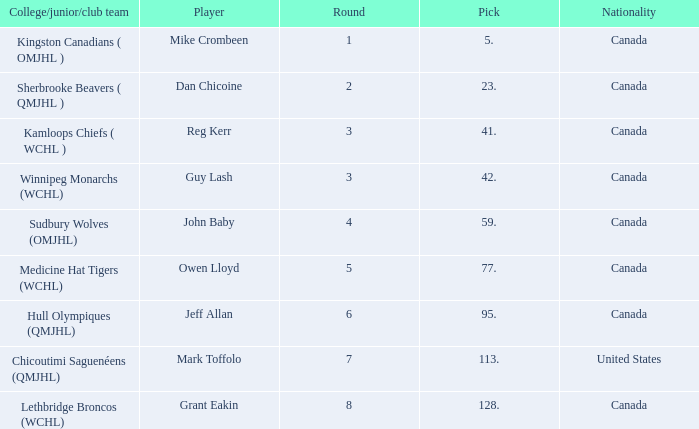Which Round has a Player of dan chicoine, and a Pick larger than 23? None. 